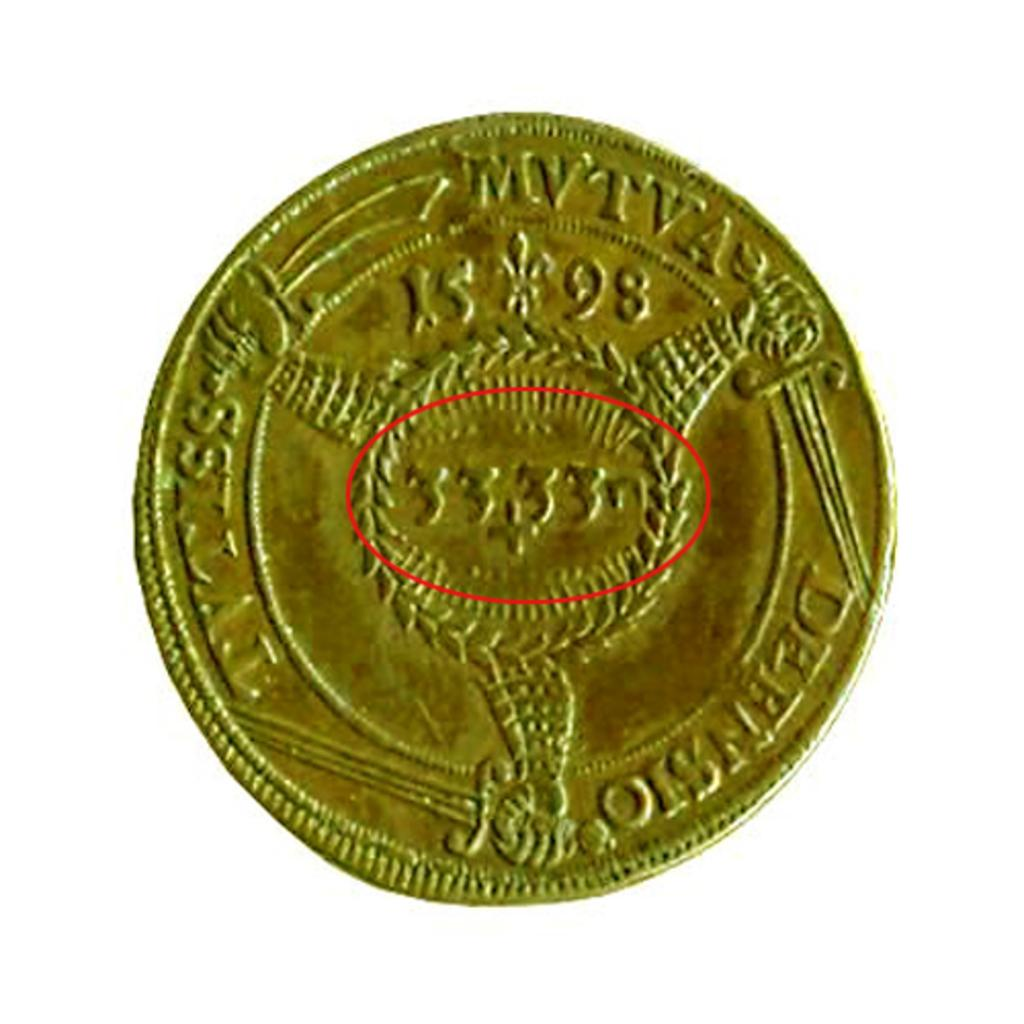<image>
Present a compact description of the photo's key features. old gold coin with 1598 on it and letters MVTVA 